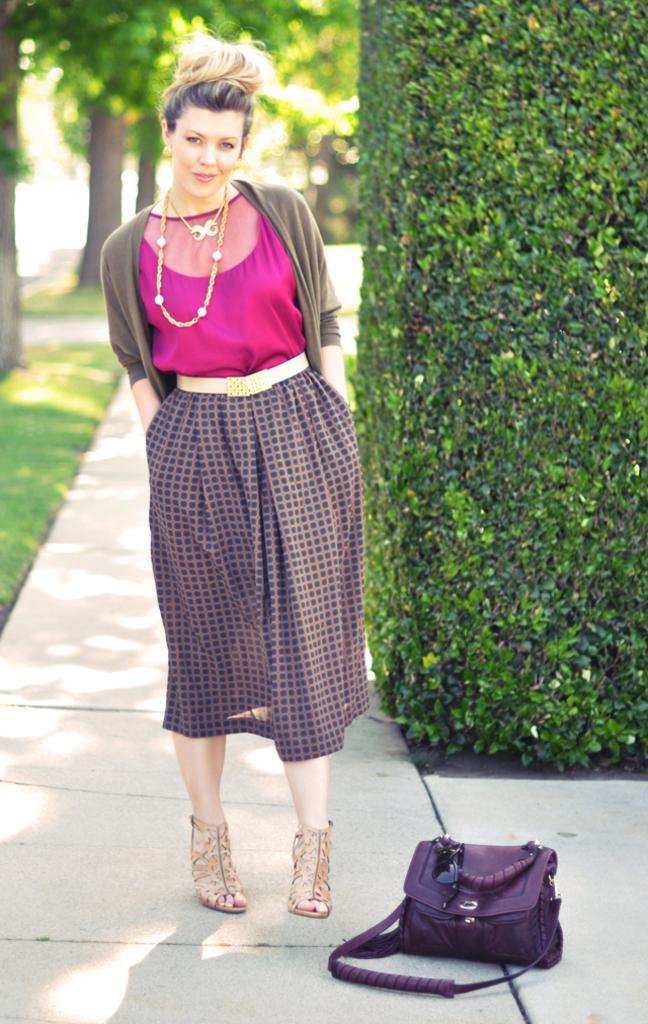Can you describe this image briefly? In the middle of the image a woman is standing and smiling behind her there are some trees. Bottom left side of the image there is grass. Bottom right side of the image there is a bag. 